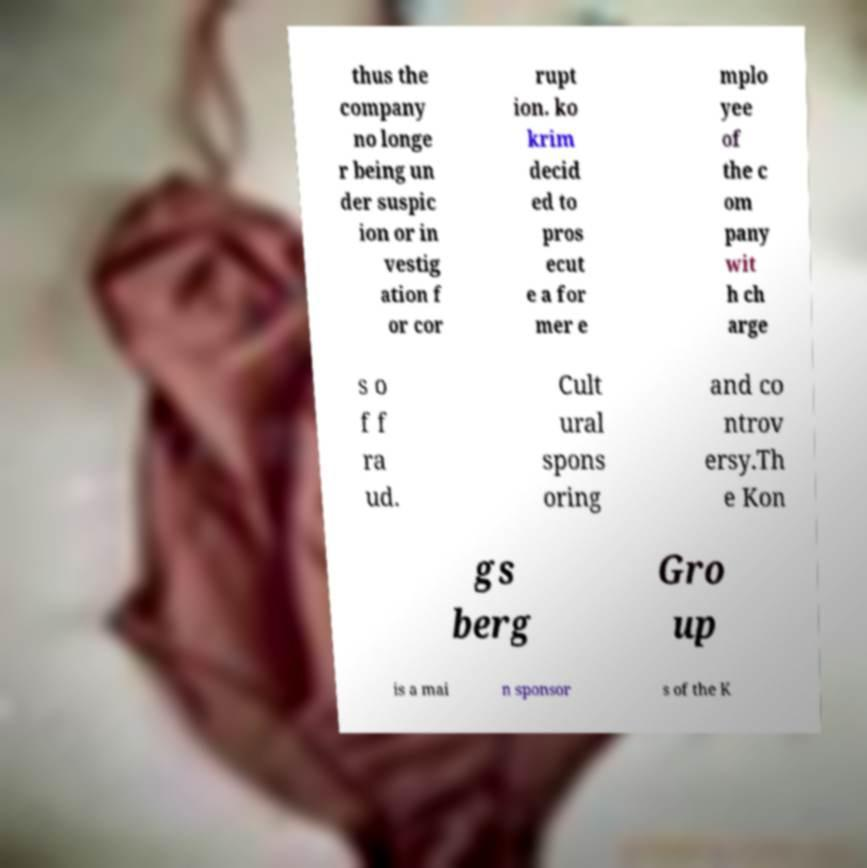For documentation purposes, I need the text within this image transcribed. Could you provide that? thus the company no longe r being un der suspic ion or in vestig ation f or cor rupt ion. ko krim decid ed to pros ecut e a for mer e mplo yee of the c om pany wit h ch arge s o f f ra ud. Cult ural spons oring and co ntrov ersy.Th e Kon gs berg Gro up is a mai n sponsor s of the K 